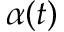<formula> <loc_0><loc_0><loc_500><loc_500>\alpha ( t )</formula> 